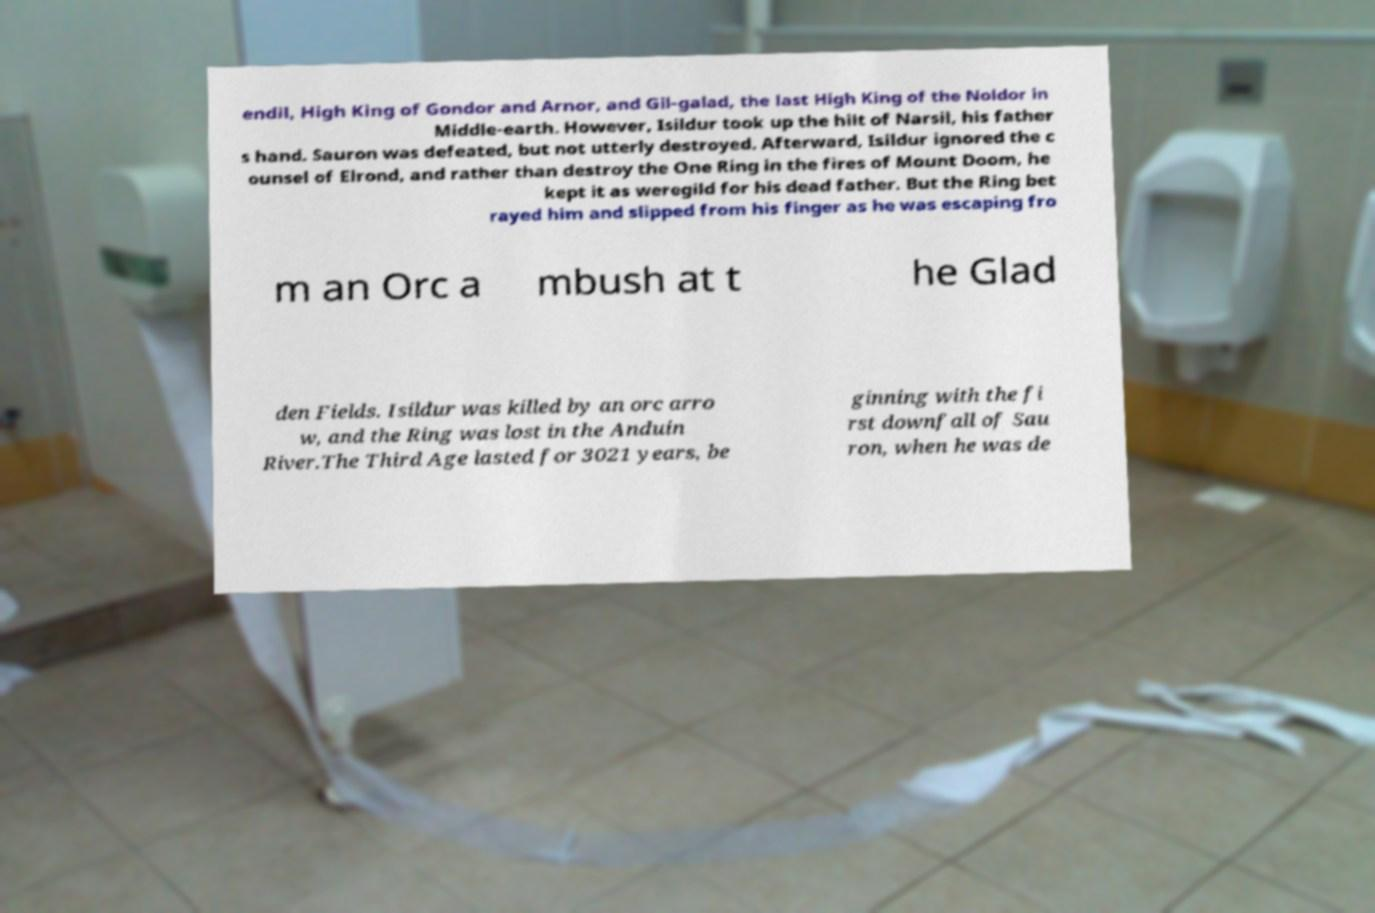Could you extract and type out the text from this image? endil, High King of Gondor and Arnor, and Gil-galad, the last High King of the Noldor in Middle-earth. However, Isildur took up the hilt of Narsil, his father s hand. Sauron was defeated, but not utterly destroyed. Afterward, Isildur ignored the c ounsel of Elrond, and rather than destroy the One Ring in the fires of Mount Doom, he kept it as weregild for his dead father. But the Ring bet rayed him and slipped from his finger as he was escaping fro m an Orc a mbush at t he Glad den Fields. Isildur was killed by an orc arro w, and the Ring was lost in the Anduin River.The Third Age lasted for 3021 years, be ginning with the fi rst downfall of Sau ron, when he was de 